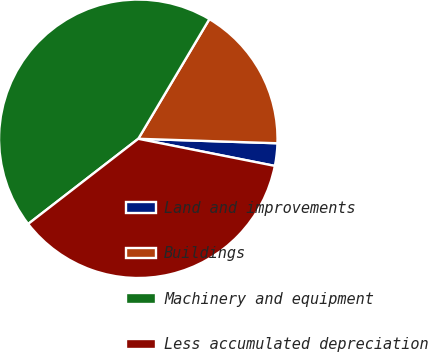Convert chart to OTSL. <chart><loc_0><loc_0><loc_500><loc_500><pie_chart><fcel>Land and improvements<fcel>Buildings<fcel>Machinery and equipment<fcel>Less accumulated depreciation<nl><fcel>2.61%<fcel>16.98%<fcel>44.01%<fcel>36.4%<nl></chart> 